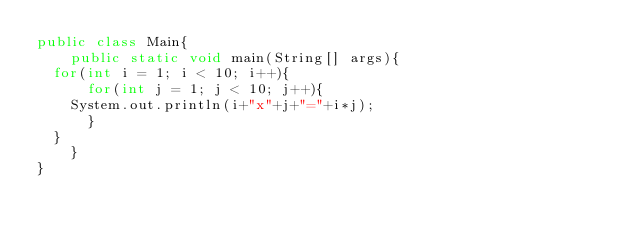Convert code to text. <code><loc_0><loc_0><loc_500><loc_500><_Java_>public class Main{
    public static void main(String[] args){
	for(int i = 1; i < 10; i++){
	    for(int j = 1; j < 10; j++){
		System.out.println(i+"x"+j+"="+i*j);
	    }
	}
    }
}</code> 